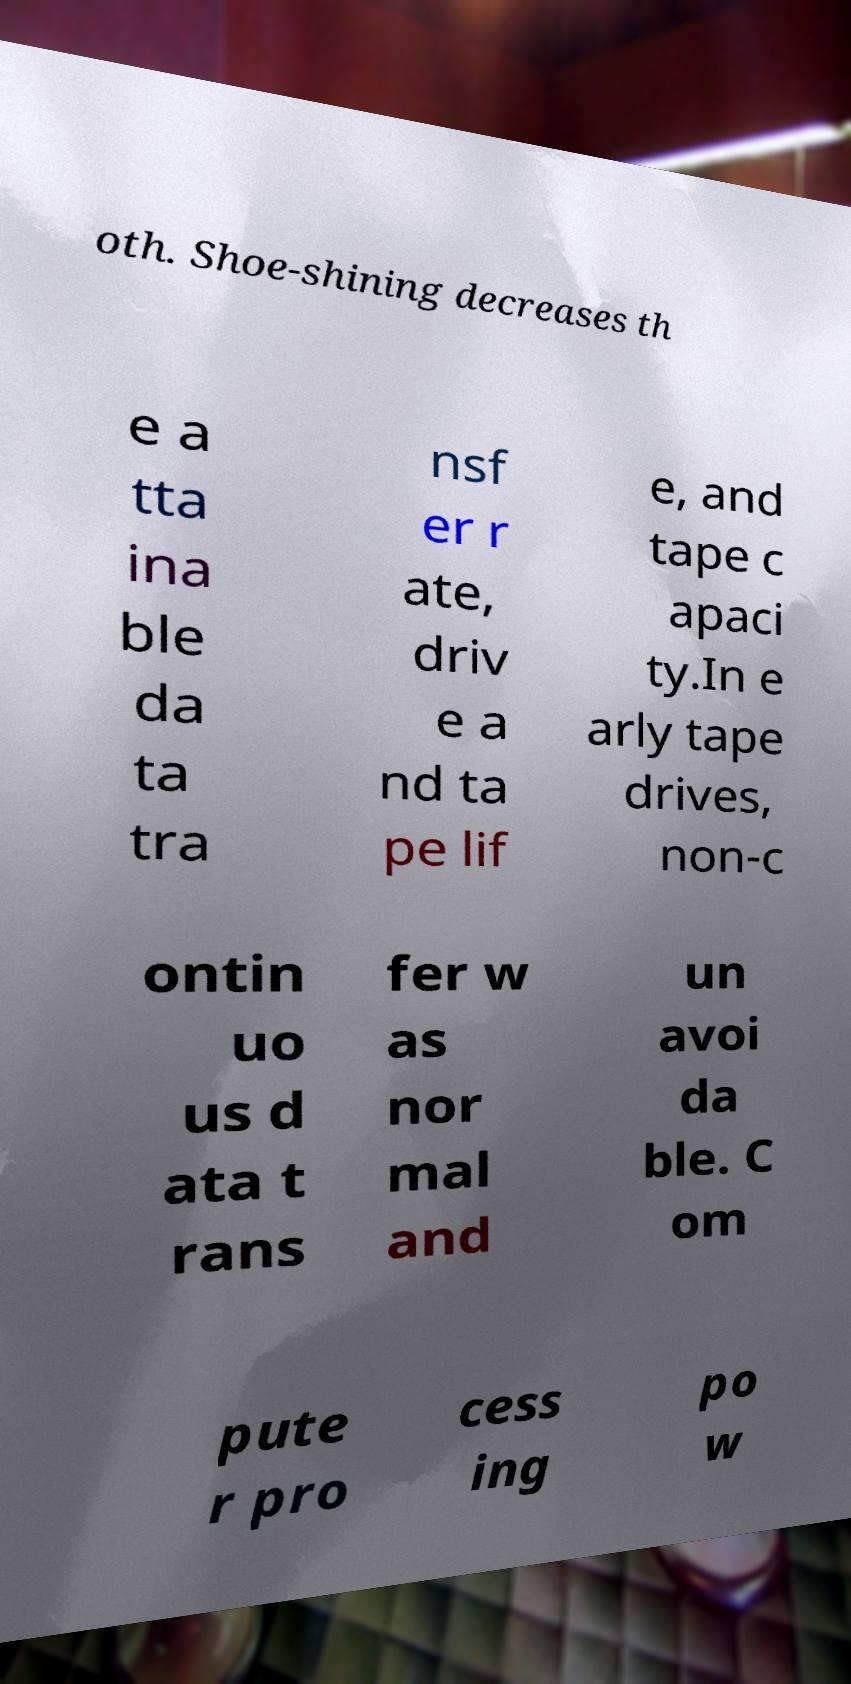There's text embedded in this image that I need extracted. Can you transcribe it verbatim? oth. Shoe-shining decreases th e a tta ina ble da ta tra nsf er r ate, driv e a nd ta pe lif e, and tape c apaci ty.In e arly tape drives, non-c ontin uo us d ata t rans fer w as nor mal and un avoi da ble. C om pute r pro cess ing po w 